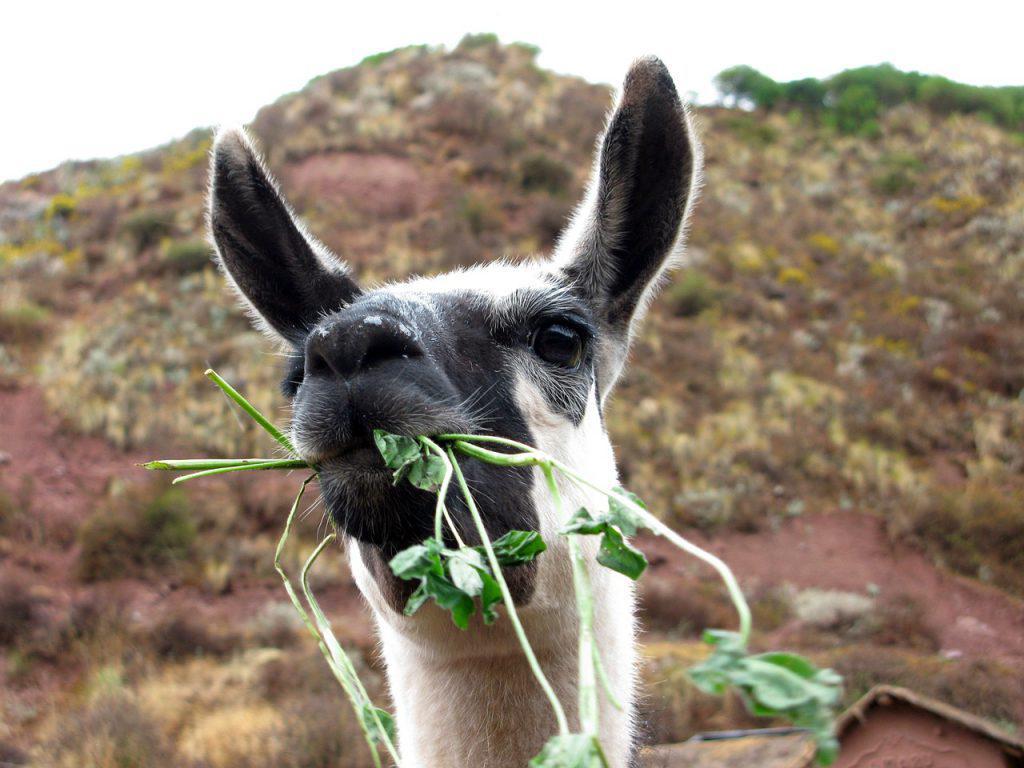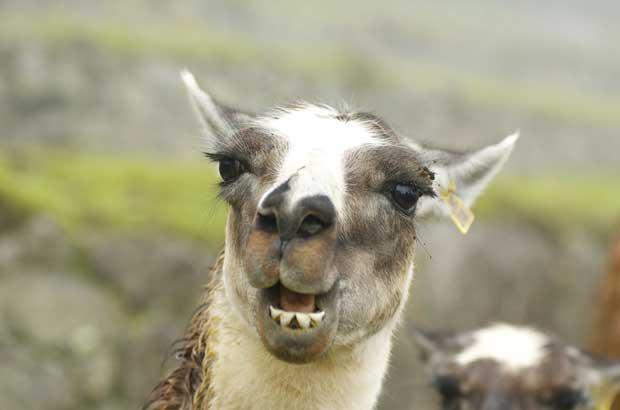The first image is the image on the left, the second image is the image on the right. Considering the images on both sides, is "An image contains a llama clenching something in its mouth." valid? Answer yes or no. Yes. The first image is the image on the left, the second image is the image on the right. For the images shown, is this caption "At least one llama is eating food." true? Answer yes or no. Yes. 